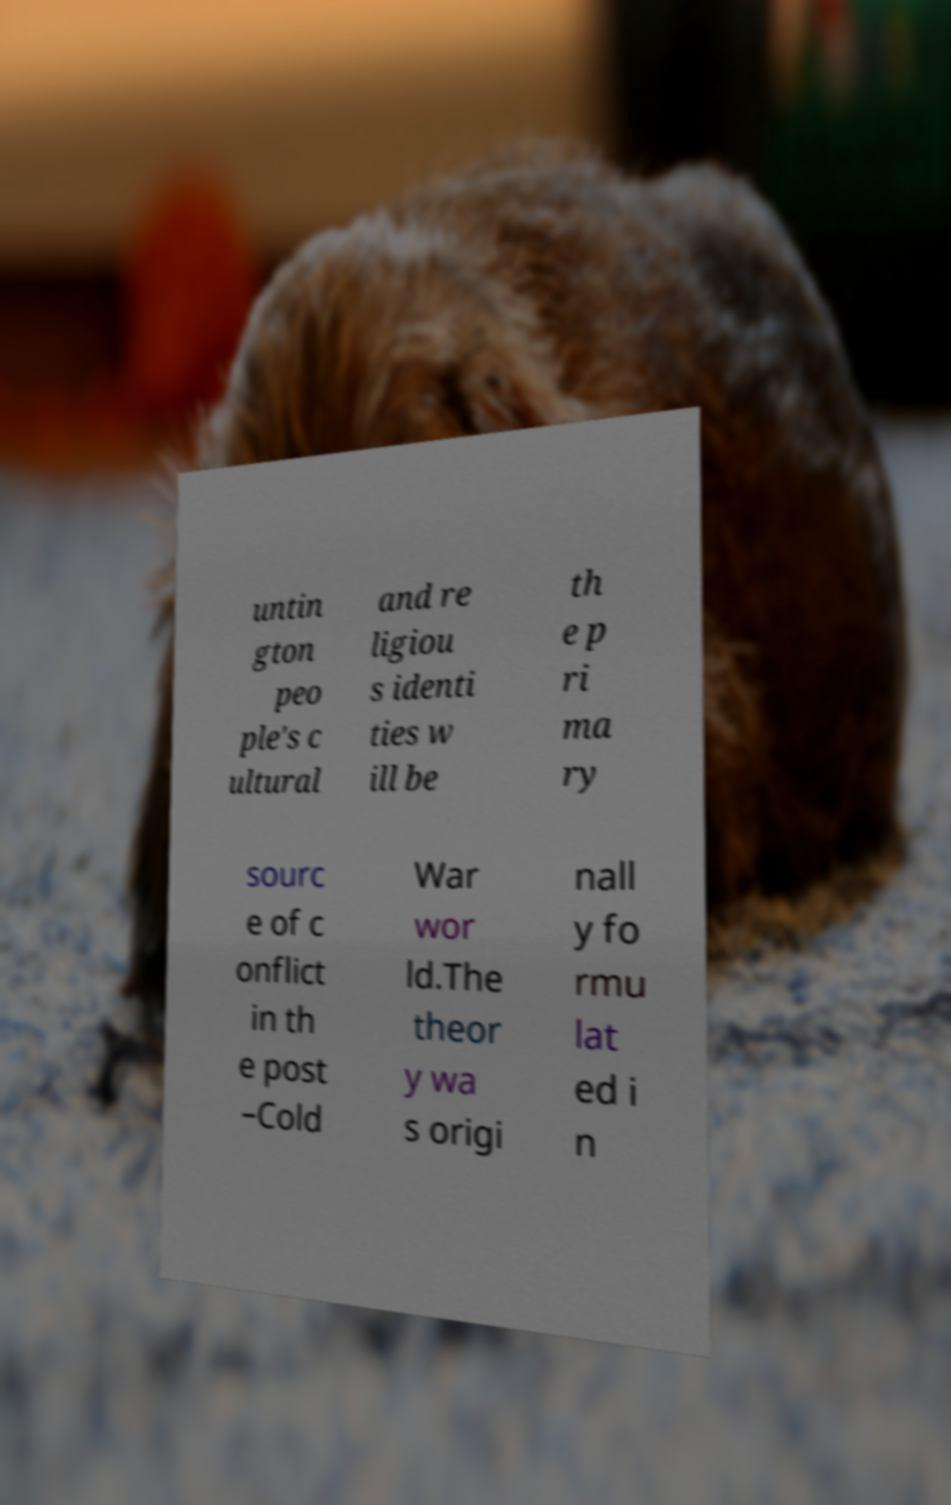Could you assist in decoding the text presented in this image and type it out clearly? untin gton peo ple's c ultural and re ligiou s identi ties w ill be th e p ri ma ry sourc e of c onflict in th e post –Cold War wor ld.The theor y wa s origi nall y fo rmu lat ed i n 